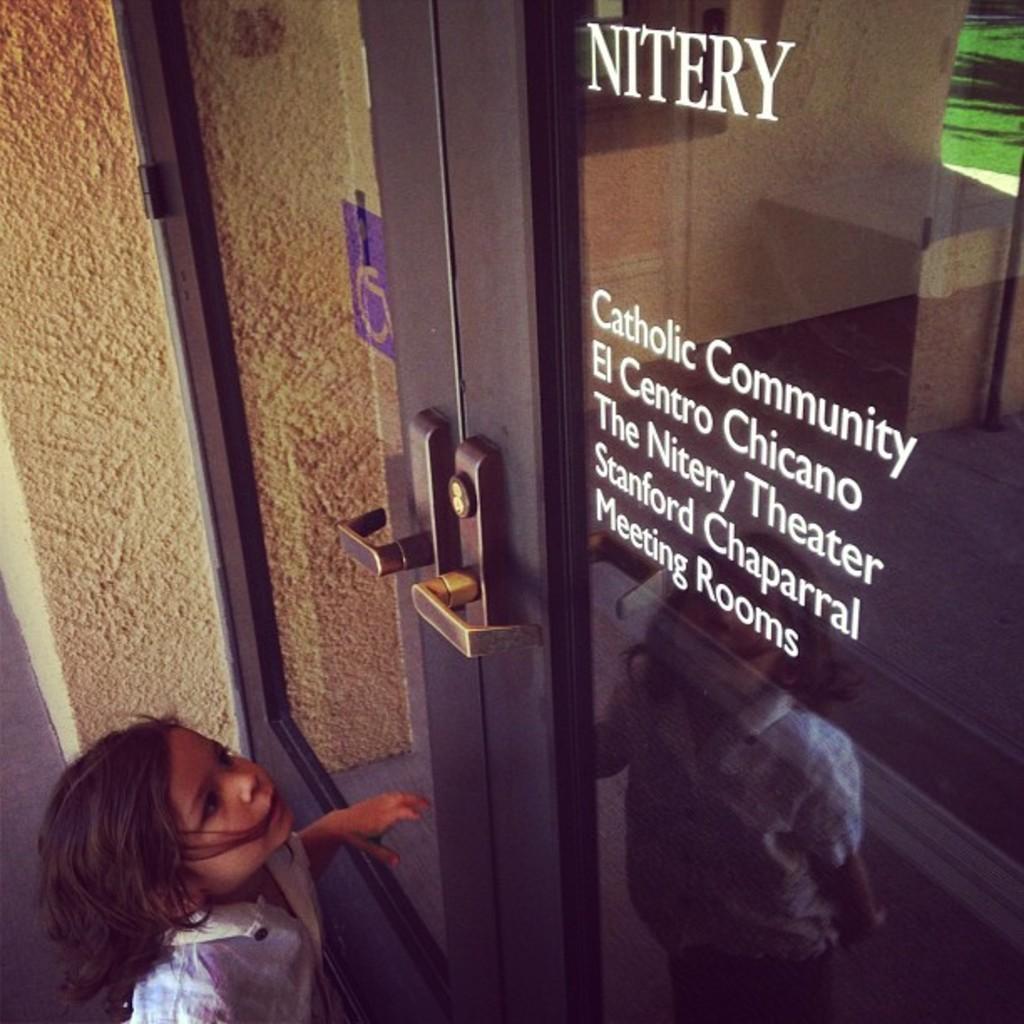Can you describe this image briefly? At the bottom of the image there is a girl and we can see a wall. There is a door. 